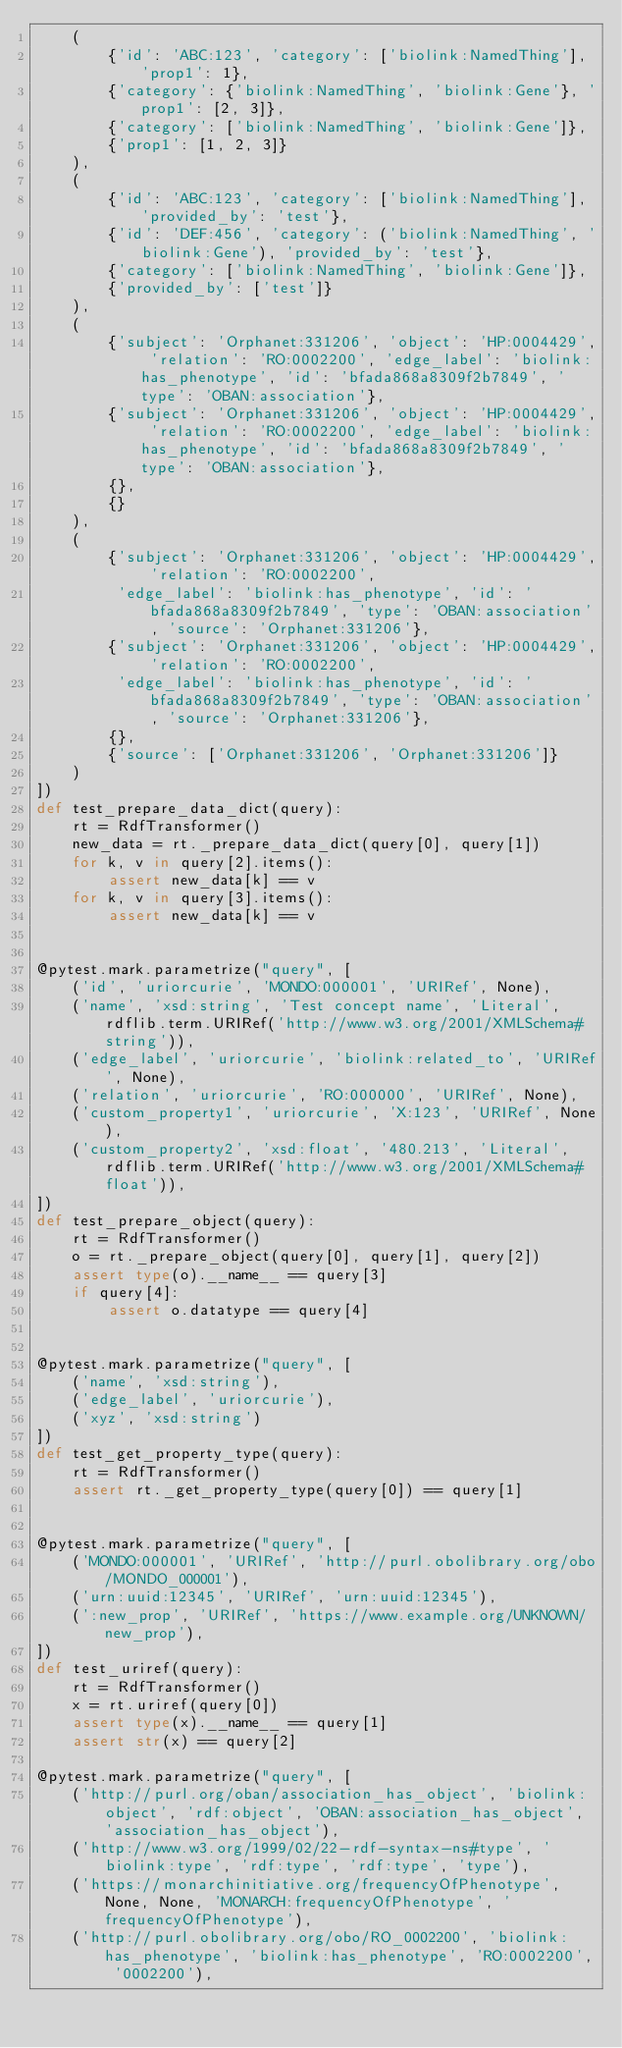Convert code to text. <code><loc_0><loc_0><loc_500><loc_500><_Python_>    (
        {'id': 'ABC:123', 'category': ['biolink:NamedThing'], 'prop1': 1},
        {'category': {'biolink:NamedThing', 'biolink:Gene'}, 'prop1': [2, 3]},
        {'category': ['biolink:NamedThing', 'biolink:Gene']},
        {'prop1': [1, 2, 3]}
    ),
    (
        {'id': 'ABC:123', 'category': ['biolink:NamedThing'], 'provided_by': 'test'},
        {'id': 'DEF:456', 'category': ('biolink:NamedThing', 'biolink:Gene'), 'provided_by': 'test'},
        {'category': ['biolink:NamedThing', 'biolink:Gene']},
        {'provided_by': ['test']}
    ),
    (
        {'subject': 'Orphanet:331206', 'object': 'HP:0004429', 'relation': 'RO:0002200', 'edge_label': 'biolink:has_phenotype', 'id': 'bfada868a8309f2b7849', 'type': 'OBAN:association'},
        {'subject': 'Orphanet:331206', 'object': 'HP:0004429', 'relation': 'RO:0002200', 'edge_label': 'biolink:has_phenotype', 'id': 'bfada868a8309f2b7849', 'type': 'OBAN:association'},
        {},
        {}
    ),
    (
        {'subject': 'Orphanet:331206', 'object': 'HP:0004429', 'relation': 'RO:0002200',
         'edge_label': 'biolink:has_phenotype', 'id': 'bfada868a8309f2b7849', 'type': 'OBAN:association', 'source': 'Orphanet:331206'},
        {'subject': 'Orphanet:331206', 'object': 'HP:0004429', 'relation': 'RO:0002200',
         'edge_label': 'biolink:has_phenotype', 'id': 'bfada868a8309f2b7849', 'type': 'OBAN:association', 'source': 'Orphanet:331206'},
        {},
        {'source': ['Orphanet:331206', 'Orphanet:331206']}
    )
])
def test_prepare_data_dict(query):
    rt = RdfTransformer()
    new_data = rt._prepare_data_dict(query[0], query[1])
    for k, v in query[2].items():
        assert new_data[k] == v
    for k, v in query[3].items():
        assert new_data[k] == v


@pytest.mark.parametrize("query", [
    ('id', 'uriorcurie', 'MONDO:000001', 'URIRef', None),
    ('name', 'xsd:string', 'Test concept name', 'Literal', rdflib.term.URIRef('http://www.w3.org/2001/XMLSchema#string')),
    ('edge_label', 'uriorcurie', 'biolink:related_to', 'URIRef', None),
    ('relation', 'uriorcurie', 'RO:000000', 'URIRef', None),
    ('custom_property1', 'uriorcurie', 'X:123', 'URIRef', None),
    ('custom_property2', 'xsd:float', '480.213', 'Literal', rdflib.term.URIRef('http://www.w3.org/2001/XMLSchema#float')),
])
def test_prepare_object(query):
    rt = RdfTransformer()
    o = rt._prepare_object(query[0], query[1], query[2])
    assert type(o).__name__ == query[3]
    if query[4]:
        assert o.datatype == query[4]


@pytest.mark.parametrize("query", [
    ('name', 'xsd:string'),
    ('edge_label', 'uriorcurie'),
    ('xyz', 'xsd:string')
])
def test_get_property_type(query):
    rt = RdfTransformer()
    assert rt._get_property_type(query[0]) == query[1]


@pytest.mark.parametrize("query", [
    ('MONDO:000001', 'URIRef', 'http://purl.obolibrary.org/obo/MONDO_000001'),
    ('urn:uuid:12345', 'URIRef', 'urn:uuid:12345'),
    (':new_prop', 'URIRef', 'https://www.example.org/UNKNOWN/new_prop'),
])
def test_uriref(query):
    rt = RdfTransformer()
    x = rt.uriref(query[0])
    assert type(x).__name__ == query[1]
    assert str(x) == query[2]

@pytest.mark.parametrize("query", [
    ('http://purl.org/oban/association_has_object', 'biolink:object', 'rdf:object', 'OBAN:association_has_object', 'association_has_object'),
    ('http://www.w3.org/1999/02/22-rdf-syntax-ns#type', 'biolink:type', 'rdf:type', 'rdf:type', 'type'),
    ('https://monarchinitiative.org/frequencyOfPhenotype', None, None, 'MONARCH:frequencyOfPhenotype', 'frequencyOfPhenotype'),
    ('http://purl.obolibrary.org/obo/RO_0002200', 'biolink:has_phenotype', 'biolink:has_phenotype', 'RO:0002200', '0002200'),</code> 